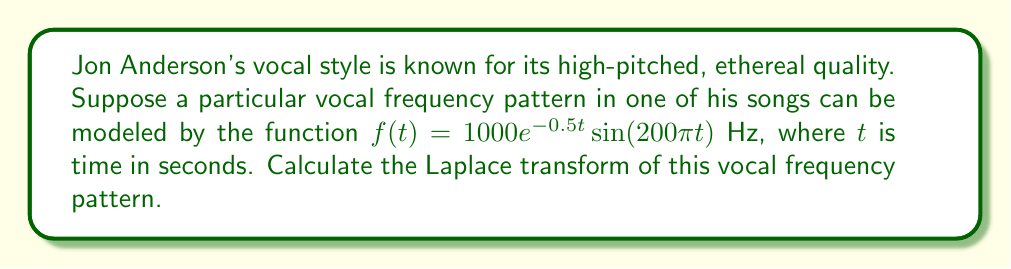Help me with this question. To solve this problem, we'll use the Laplace transform of a damped sinusoidal function. The general form of the Laplace transform for $f(t) = e^{-at}\sin(bt)$ is:

$$\mathcal{L}\{e^{-at}\sin(bt)\} = \frac{b}{(s+a)^2 + b^2}$$

In our case, we have:
$f(t) = 1000e^{-0.5t}\sin(200\pi t)$

Comparing this to the general form, we can identify:
$a = 0.5$
$b = 200\pi$
There's also a constant factor of 1000.

The Laplace transform is linear, so we can factor out the constant:

$$\mathcal{L}\{1000e^{-0.5t}\sin(200\pi t)\} = 1000 \cdot \mathcal{L}\{e^{-0.5t}\sin(200\pi t)\}$$

Now, we can apply the formula:

$$\mathcal{L}\{f(t)\} = 1000 \cdot \frac{200\pi}{(s+0.5)^2 + (200\pi)^2}$$

Simplifying:

$$\mathcal{L}\{f(t)\} = \frac{200000\pi}{s^2 + s + 40000\pi^2}$$

This is the Laplace transform of the given vocal frequency pattern.
Answer: $$\mathcal{L}\{f(t)\} = \frac{200000\pi}{s^2 + s + 40000\pi^2}$$ 